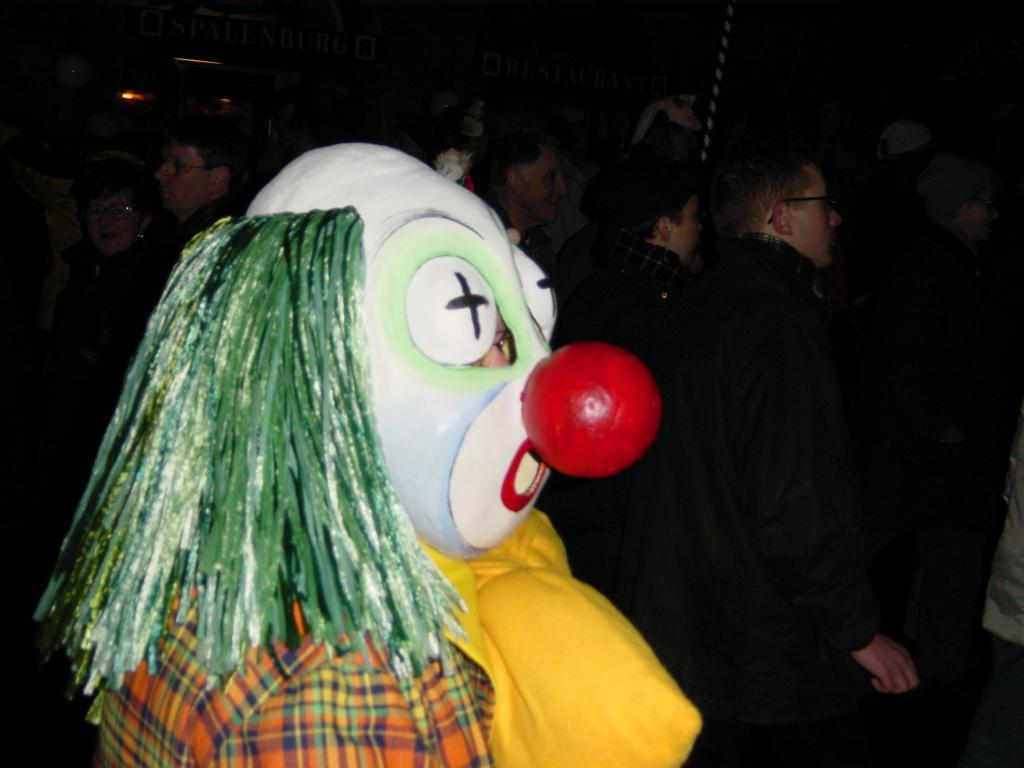What can be inferred about the location of the image? The image was likely taken indoors. What is the main subject in the foreground of the image? There is a person dressed as a clown in the foreground of the image. What else can be seen in the background of the image? There is a group of people and other objects visible in the background of the image. What type of thread is being used by the clown to play an instrument in the image? There is no clown playing an instrument in the image, nor is there any thread present. 